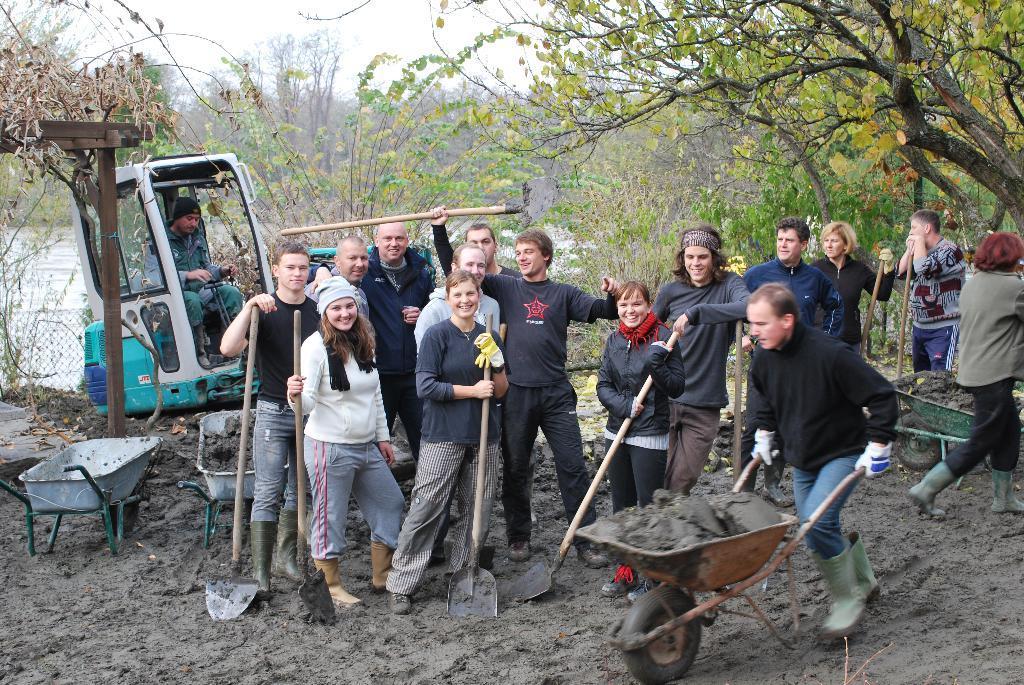Describe this image in one or two sentences. This image is taken outdoors. At the bottom of the image there is a ground. At the top of the image there is the sky. In the background there are many trees and plants on the ground. There is a pond with water and there is a mesh. There is a vehicle parked on the ground. In the middle of the image a few people are standing on the ground and they are holding spades in their hands. There are a few trolleys with mud in them. On the right side of the image a person is walking on the ground. In the middle of the image a man is walking on the ground and he is holding a trolley in his hands. 